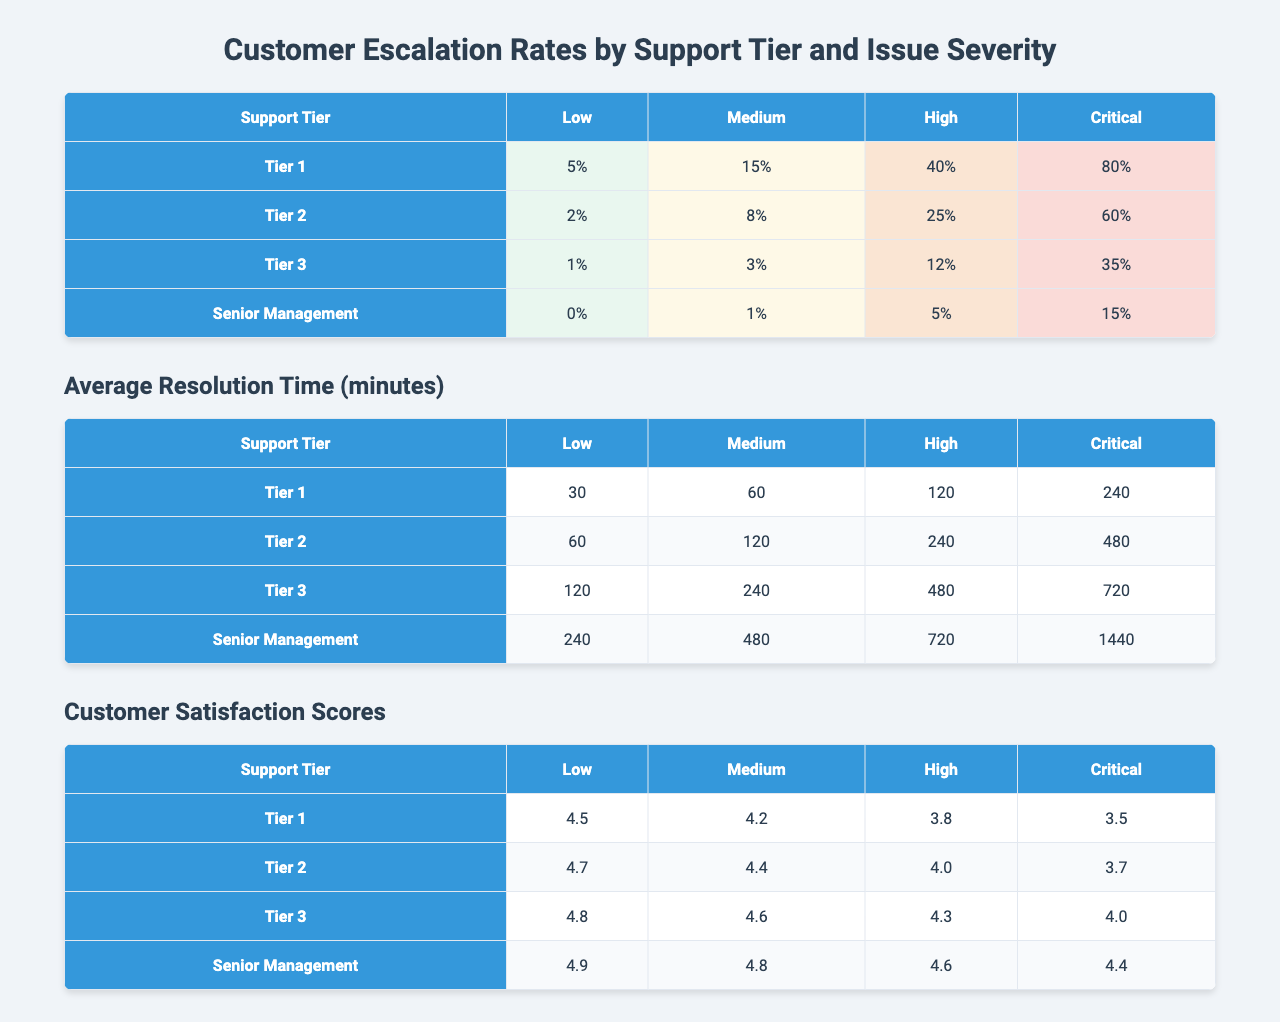What is the escalation rate for Critical severity issues at Tier 1? The table shows that the escalation rate for Critical severity issues under Tier 1 is 80%.
Answer: 80% What is the customer satisfaction score for Medium severity issues at Tier 3? The table indicates that the customer satisfaction score for Medium severity issues at Tier 3 is 4.6.
Answer: 4.6 Which support tier has the highest escalation rate for High severity issues? Tier 1 has the highest escalation rate for High severity issues at 40%, compared to other tiers.
Answer: Tier 1 What is the average escalation rate for Low severity issues across all tiers? The escalation rates for Low severity issues are 5% (Tier 1), 2% (Tier 2), 1% (Tier 3), and 0% (Senior Management). The average is (5 + 2 + 1 + 0) / 4 = 8 / 4 = 2%.
Answer: 2% Is the customer satisfaction score for Critical issues at Tier 2 higher than that at Tier 3? The customer satisfaction score for Critical issues at Tier 2 is 3.7, whereas at Tier 3, it is 4.0. Therefore, it is not higher.
Answer: No What is the resolution time for High severity issues at Senior Management? The table shows that the average resolution time for High severity issues at Senior Management is 720 minutes.
Answer: 720 minutes If we consider the escalation rates for Medium and Critical issues at Tier 2 combined, what is the total escalation rate? The escalation rates for Medium and Critical issues at Tier 2 are 8% and 60%, respectively. Adding them together gives 8 + 60 = 68%.
Answer: 68% What support tier has the lowest customer satisfaction score for Low severity issues? The customer satisfaction scores for Low severity issues are 4.5 (Tier 1), 4.7 (Tier 2), 4.8 (Tier 3), and 4.9 (Senior Management). The lowest is 4.5 from Tier 1.
Answer: Tier 1 How does the average resolution time for Critical issues compare between Tier 1 and Tier 3? The average resolution time for Critical issues is 240 minutes at Tier 1 and 720 minutes at Tier 3. Tier 1 has a shorter resolution time.
Answer: Tier 1 has a shorter resolution time If we consider all escalation rates for Low severity across all tiers, how many total are escalated? The escalation rates for Low severity are 5% (Tier 1), 2% (Tier 2), 1% (Tier 3), and 0% (Senior Management). The total escalation rate is 5 + 2 + 1 + 0 = 8%.
Answer: 8% 